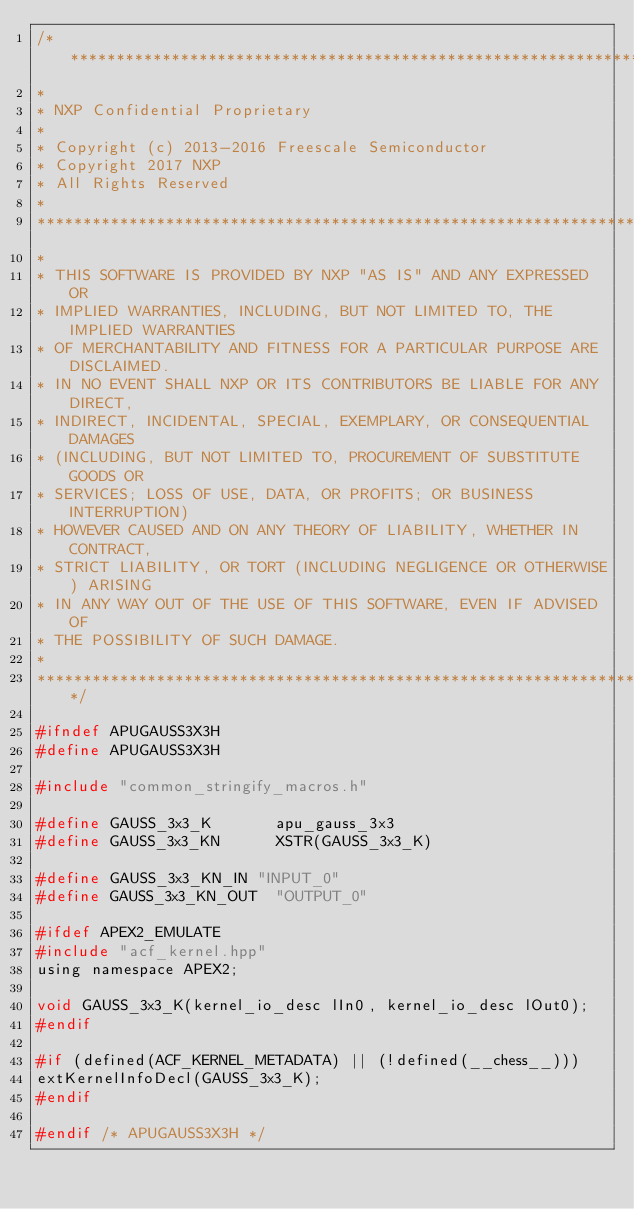<code> <loc_0><loc_0><loc_500><loc_500><_C_>/*****************************************************************************
* 
* NXP Confidential Proprietary
*
* Copyright (c) 2013-2016 Freescale Semiconductor
* Copyright 2017 NXP 
* All Rights Reserved
*
******************************************************************************
*
* THIS SOFTWARE IS PROVIDED BY NXP "AS IS" AND ANY EXPRESSED OR
* IMPLIED WARRANTIES, INCLUDING, BUT NOT LIMITED TO, THE IMPLIED WARRANTIES
* OF MERCHANTABILITY AND FITNESS FOR A PARTICULAR PURPOSE ARE DISCLAIMED.
* IN NO EVENT SHALL NXP OR ITS CONTRIBUTORS BE LIABLE FOR ANY DIRECT,
* INDIRECT, INCIDENTAL, SPECIAL, EXEMPLARY, OR CONSEQUENTIAL DAMAGES
* (INCLUDING, BUT NOT LIMITED TO, PROCUREMENT OF SUBSTITUTE GOODS OR
* SERVICES; LOSS OF USE, DATA, OR PROFITS; OR BUSINESS INTERRUPTION)
* HOWEVER CAUSED AND ON ANY THEORY OF LIABILITY, WHETHER IN CONTRACT,
* STRICT LIABILITY, OR TORT (INCLUDING NEGLIGENCE OR OTHERWISE) ARISING
* IN ANY WAY OUT OF THE USE OF THIS SOFTWARE, EVEN IF ADVISED OF
* THE POSSIBILITY OF SUCH DAMAGE.
*
****************************************************************************/

#ifndef APUGAUSS3X3H
#define APUGAUSS3X3H

#include "common_stringify_macros.h"

#define	GAUSS_3x3_K				apu_gauss_3x3
#define GAUSS_3x3_KN			XSTR(GAUSS_3x3_K)

#define GAUSS_3x3_KN_IN	"INPUT_0"
#define GAUSS_3x3_KN_OUT	"OUTPUT_0"

#ifdef APEX2_EMULATE
#include "acf_kernel.hpp"
using namespace APEX2;

void GAUSS_3x3_K(kernel_io_desc lIn0, kernel_io_desc lOut0);
#endif

#if (defined(ACF_KERNEL_METADATA) || (!defined(__chess__)))
extKernelInfoDecl(GAUSS_3x3_K);
#endif

#endif /* APUGAUSS3X3H */
</code> 